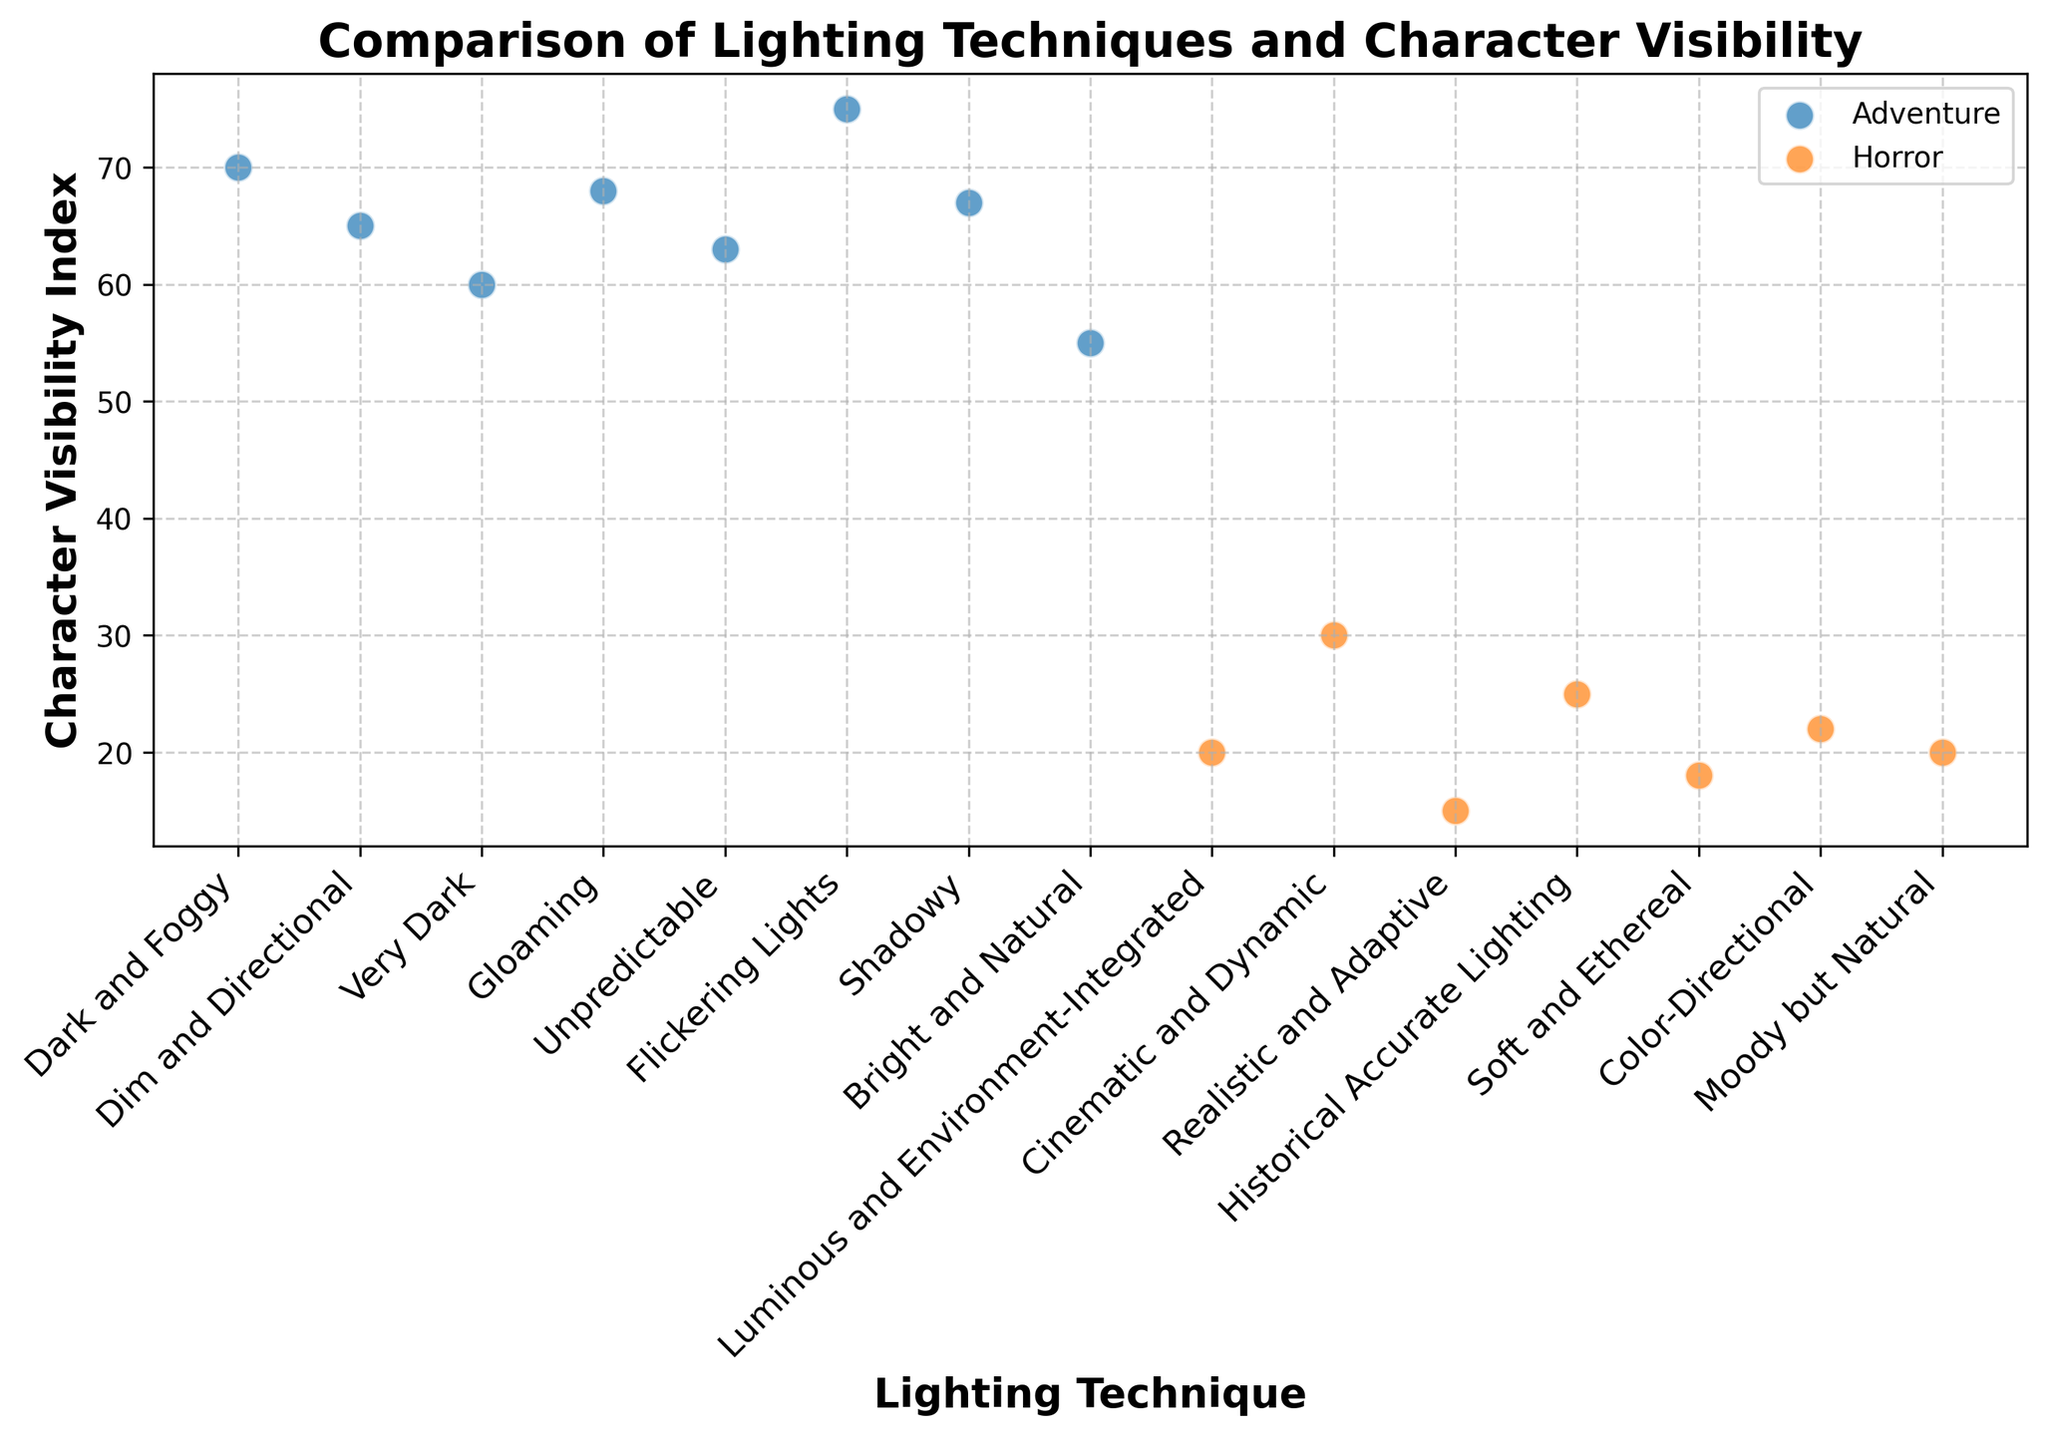What is the overall trend of character visibility in adventure versus horror games? The figure shows two distinct groupings according to the game type. Adventure games have a higher Character Visibility Index (ranging around 55 to 75), whereas horror games have a generally lower character visibility (ranging around 15 to 30). This suggests that adventure games use lighting techniques that result in higher character visibility compared to horror games.
Answer: Adventure games have higher character visibility than horror games Which game has the highest character visibility index? By looking at the scatter plot, the data point with the highest character visibility index falls within the adventure games group. Identifying the exact point, "Journey" from the adventure games has a Character Visibility Index of 75, which is the highest.
Answer: Journey Compare the character visibility index of "Silent Hill" and "Detroit: Become Human." Which is higher? Locate both games on the scatter plot. "Silent Hill" has a character visibility index of 20, while "Detroit: Become Human" has a higher value of 70. Thus, "Detroit: Become Human" has a higher character visibility index.
Answer: Detroit: Become Human What is the difference between the character visibility indices of "Resident Evil" and "Uncharted"? Locate both games on the scatter plot. "Resident Evil" has a character visibility index of 30, and "Uncharted" has an index of 60. Calculate the difference: 60 - 30 = 30.
Answer: 30 Which lighting technique is associated with the lowest character visibility index? From the scatter plot, identify the data point with the lowest character visibility index. The point indicating the lowest visibility (index of 15) corresponds to "Amnesia" which uses the "Very Dark" lighting technique.
Answer: Very Dark What is the average character visibility index of adventure games? To find the average, identify the character visibility indices of all adventure games: 70, 65, 60, 68, 63, 75, 67, 55. Sum these values: 70 + 65 + 60 + 68 + 63 + 75 + 67 + 55 = 523. Divide by the number of games (8): 523 / 8 = 65.375, approximately 65.38.
Answer: 65.38 Compare the character visibility index variability between horror and adventure games. To compare variability, observe the range of visibility indices in the scatter plot. Horror games span from 15 to 30, a range of 15. Adventure games span from 55 to 75, a wider range of 20. This indicates that adventure games display more variability in their character visibility indices compared to horror games.
Answer: Adventure games have more variability How many games have a character visibility index greater than 60? Scan the scatter plot for data points above the 60 mark. Adventure games are generally above this threshold: "Detroit: Become Human", "The Legend of Zelda", "Uncharted", "Tomb Raider", "Journey", and "The Witness". Count each data point to find that there are 6 such games.
Answer: 6 